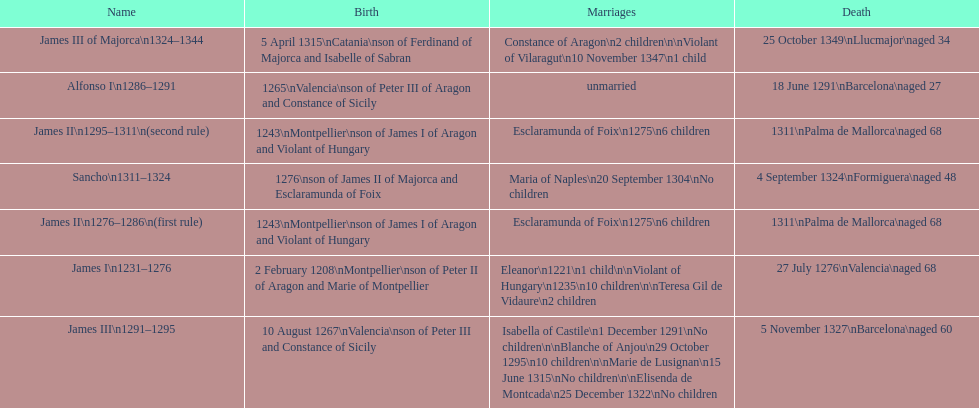Who came to power after the rule of james iii? James II. 